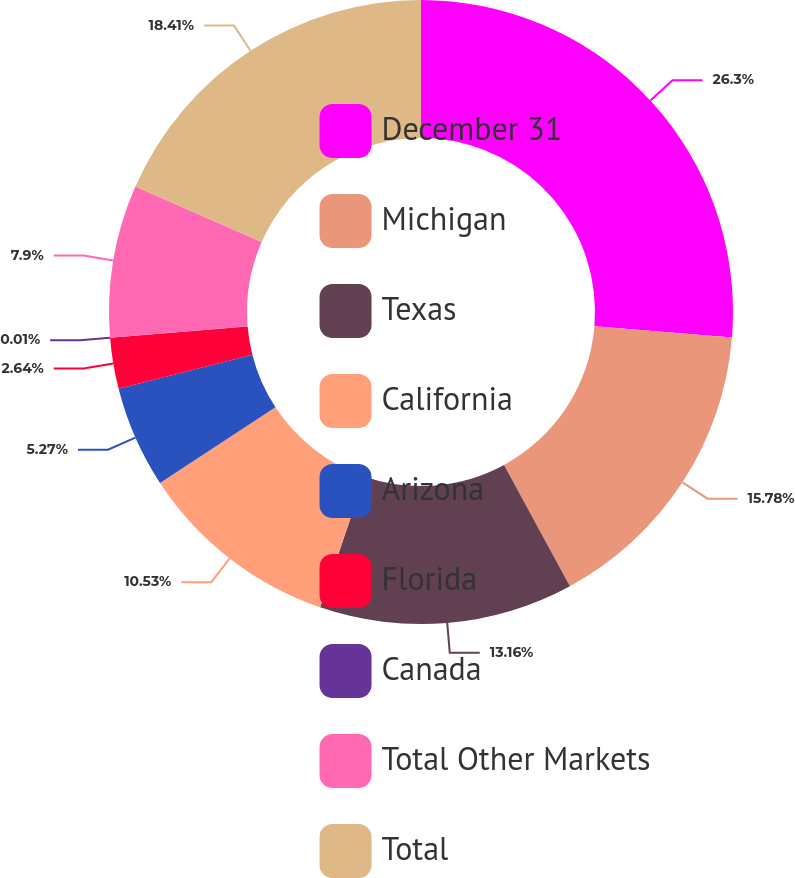Convert chart to OTSL. <chart><loc_0><loc_0><loc_500><loc_500><pie_chart><fcel>December 31<fcel>Michigan<fcel>Texas<fcel>California<fcel>Arizona<fcel>Florida<fcel>Canada<fcel>Total Other Markets<fcel>Total<nl><fcel>26.3%<fcel>15.78%<fcel>13.16%<fcel>10.53%<fcel>5.27%<fcel>2.64%<fcel>0.01%<fcel>7.9%<fcel>18.41%<nl></chart> 